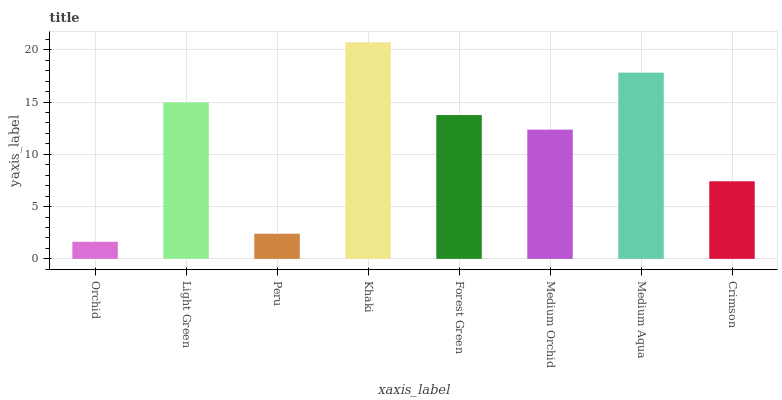Is Orchid the minimum?
Answer yes or no. Yes. Is Khaki the maximum?
Answer yes or no. Yes. Is Light Green the minimum?
Answer yes or no. No. Is Light Green the maximum?
Answer yes or no. No. Is Light Green greater than Orchid?
Answer yes or no. Yes. Is Orchid less than Light Green?
Answer yes or no. Yes. Is Orchid greater than Light Green?
Answer yes or no. No. Is Light Green less than Orchid?
Answer yes or no. No. Is Forest Green the high median?
Answer yes or no. Yes. Is Medium Orchid the low median?
Answer yes or no. Yes. Is Medium Aqua the high median?
Answer yes or no. No. Is Light Green the low median?
Answer yes or no. No. 